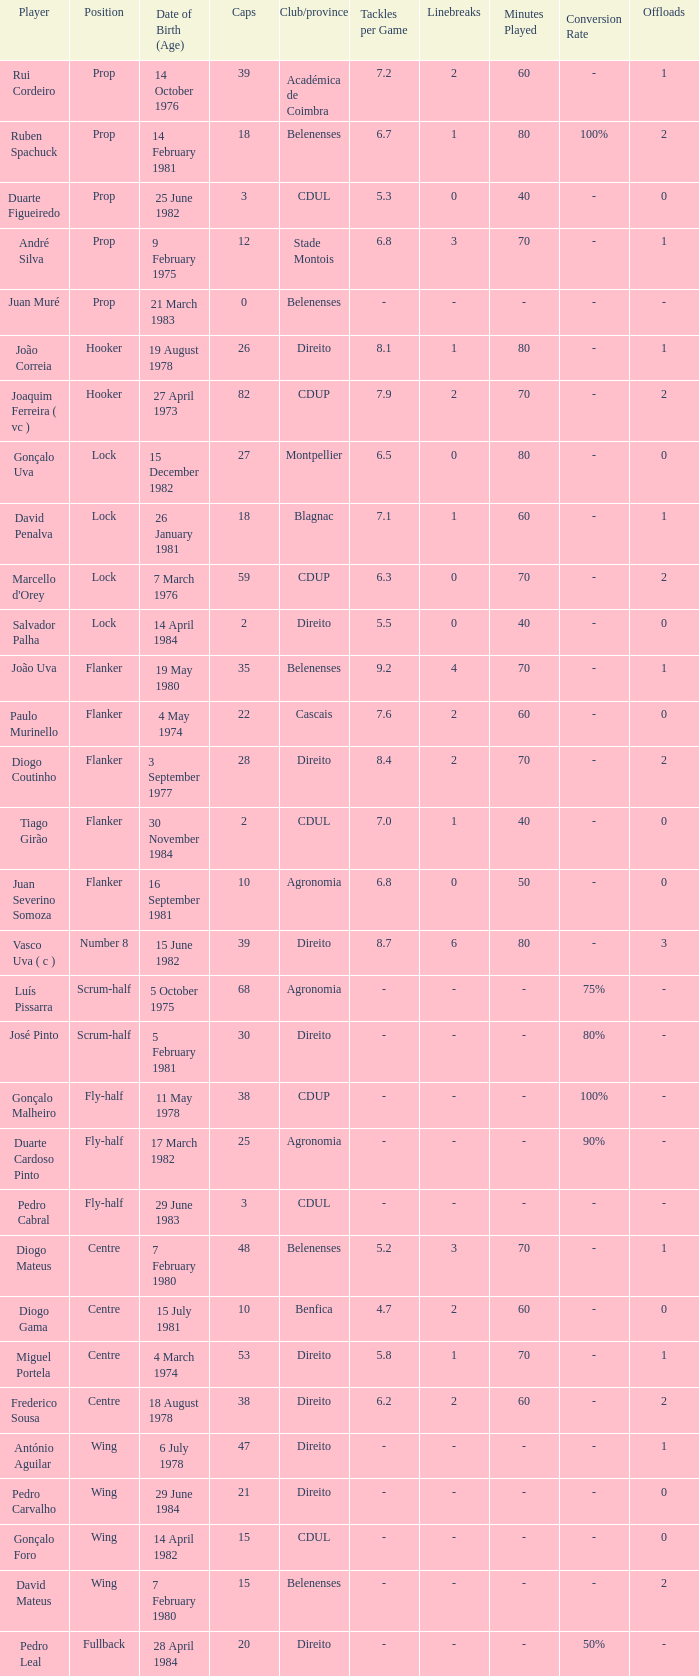Which player has a Position of fly-half, and a Caps of 3? Pedro Cabral. 